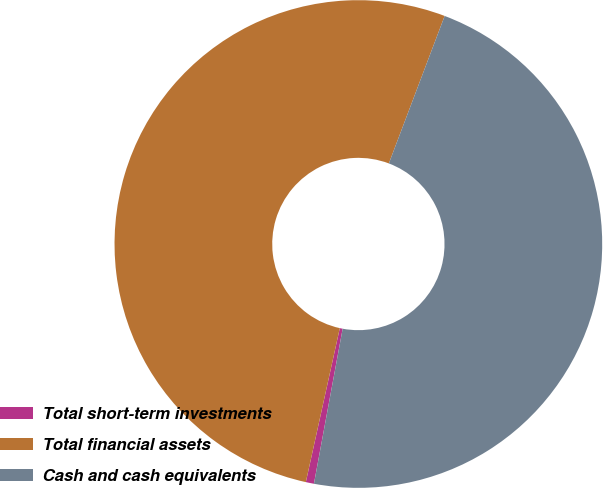Convert chart. <chart><loc_0><loc_0><loc_500><loc_500><pie_chart><fcel>Total short-term investments<fcel>Total financial assets<fcel>Cash and cash equivalents<nl><fcel>0.54%<fcel>52.3%<fcel>47.16%<nl></chart> 